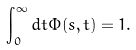Convert formula to latex. <formula><loc_0><loc_0><loc_500><loc_500>\int _ { 0 } ^ { \infty } d t \Phi ( s , t ) = 1 .</formula> 